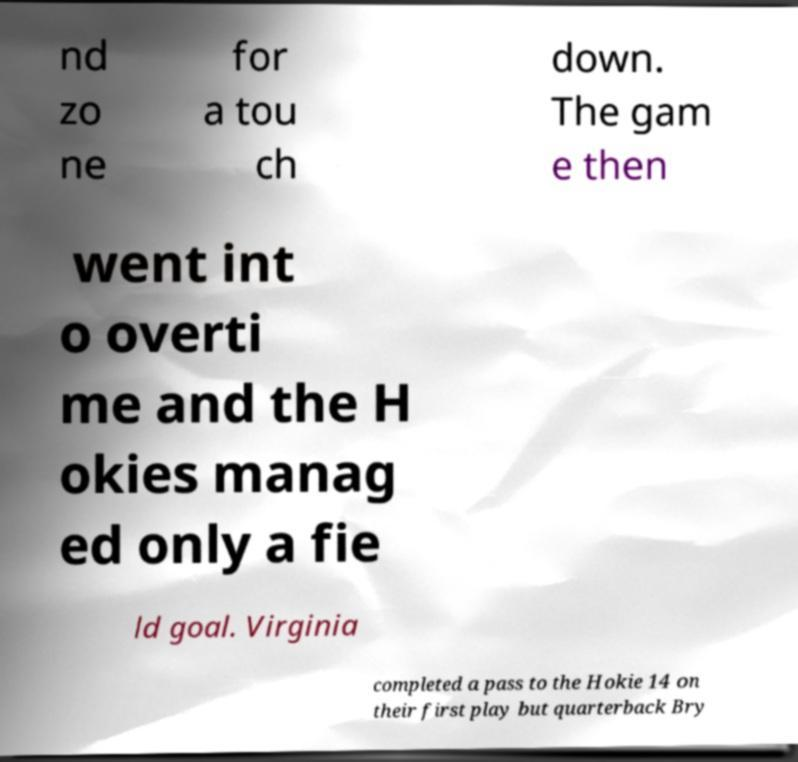I need the written content from this picture converted into text. Can you do that? nd zo ne for a tou ch down. The gam e then went int o overti me and the H okies manag ed only a fie ld goal. Virginia completed a pass to the Hokie 14 on their first play but quarterback Bry 